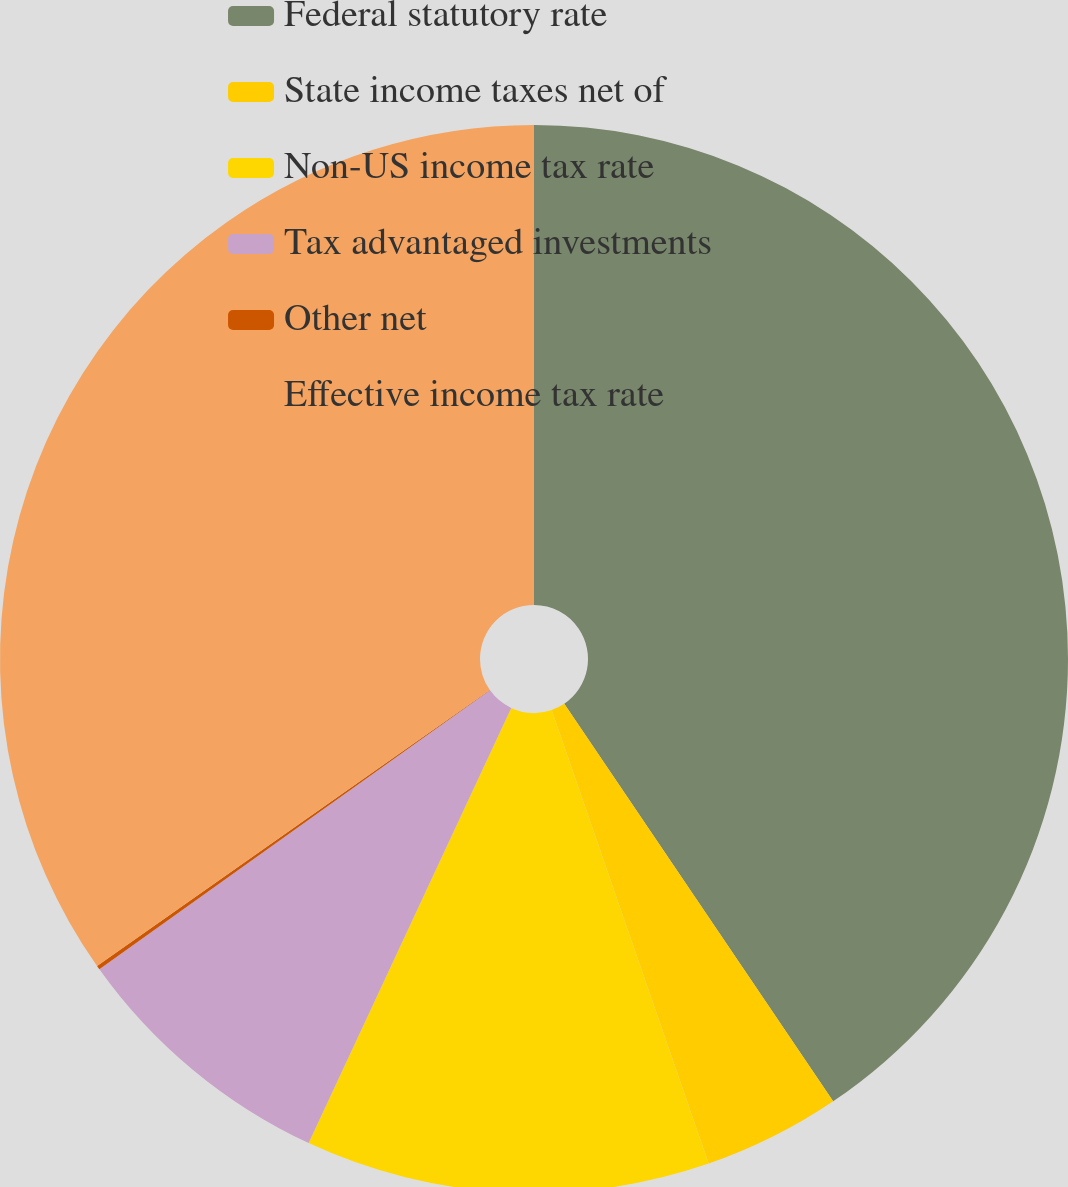Convert chart. <chart><loc_0><loc_0><loc_500><loc_500><pie_chart><fcel>Federal statutory rate<fcel>State income taxes net of<fcel>Non-US income tax rate<fcel>Tax advantaged investments<fcel>Other net<fcel>Effective income tax rate<nl><fcel>40.54%<fcel>4.16%<fcel>12.24%<fcel>8.2%<fcel>0.12%<fcel>34.75%<nl></chart> 